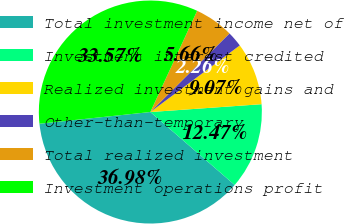<chart> <loc_0><loc_0><loc_500><loc_500><pie_chart><fcel>Total investment income net of<fcel>Investment interest credited<fcel>Realized investment gains and<fcel>Other-than-temporary<fcel>Total realized investment<fcel>Investment operations profit<nl><fcel>36.98%<fcel>12.47%<fcel>9.07%<fcel>2.26%<fcel>5.66%<fcel>33.57%<nl></chart> 